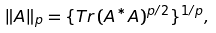Convert formula to latex. <formula><loc_0><loc_0><loc_500><loc_500>\| A \| _ { p } = \{ { T r \, } ( A ^ { * } A ) ^ { p / 2 } \} ^ { 1 / p } ,</formula> 